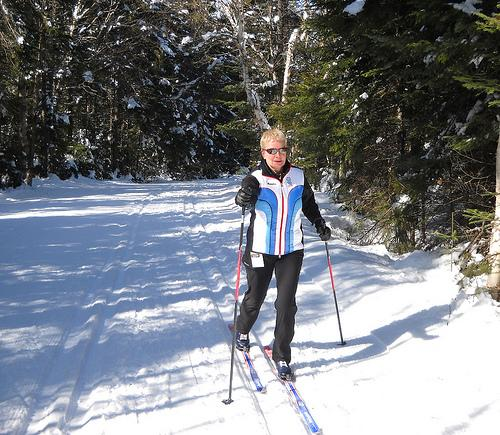Using emojis, describe the scene of a woman skiing through the snowy path. 👩❄️🎿🌲 Write a catchy sentence for a product advertisement that would feature this woman skiing. Conquer the slopes in style with our vibrant, high-performance ski gear, designed for the bold modern woman! Briefly describe the state of the snow and the path the skier is traveling on. The snow is white, and the skier is traveling on a well-trodden path with tracks from other skiers. In a colloquial manner, describe the environment surrounding the woman skiing. The place is all covered in white snow, with tracks from other skiers and nice green trees lined up along the path. Explain the action portrayed and mention the most noticeable color in the woman’s outfit. The woman is skiing through the snow and her jacket has noticeable blue and red stripes. In the context of a multi-choice VQA task, answer the following: What color are the trees in the image? The trees are green in color. Write a poetic description of the woman skiing in the image. A graceful figure glides through the snow, adorned in vibrant hues, embracing nature's winter wonderland as she conquers the frosted path. What does the lady have on her face and what is the color of her hair? The lady is wearing goggles on her face and has brown hair. List three prominent colors featured on the woman's outfit. White, black, and blue are prominent colors in the woman's outfit. Informally describe what the skier is holding in her hands. The skier has got these cool red and black ski poles in her hands. 